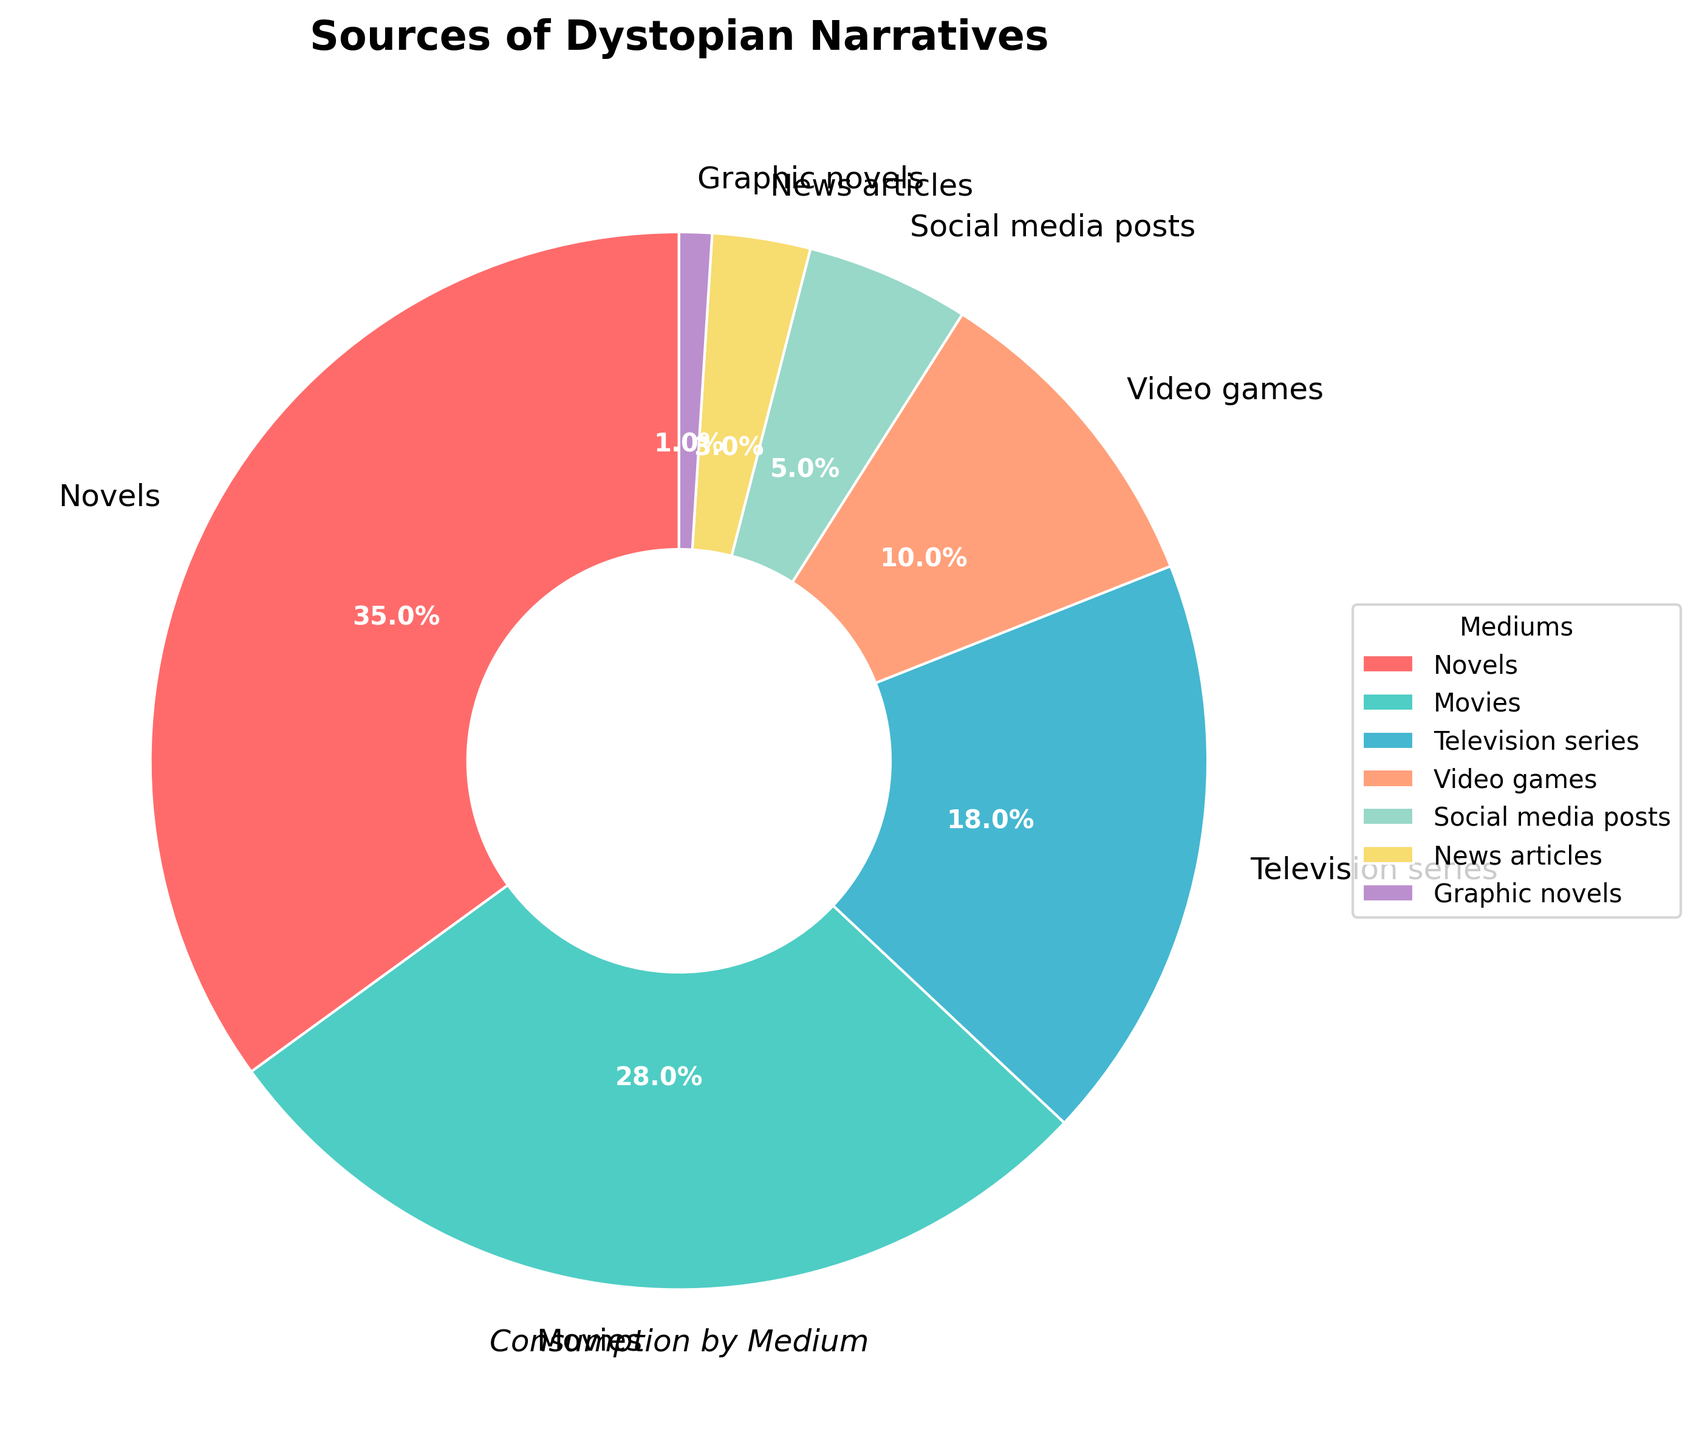Which medium has the highest percentage of dystopian narratives consumed? The pie chart shows that novels have the highest portion of the pie, indicating they have the highest percentage.
Answer: Novels What is the total percentage of dystopian narratives consumed through visual media (movies and television series)? Add the percentage of movies (28%) and television series (18%) together: 28% + 18% = 46%.
Answer: 46% Which medium has a smaller percentage of consumption, video games or social media posts? Compare the pie sections for video games (10%) and social media posts (5%). Social media posts are smaller.
Answer: Social media posts How much larger is the percentage of novels compared to news articles? Subtract the percentage of news articles (3%) from the percentage of novels (35%): 35% - 3% = 32%.
Answer: 32% What is the combined percentage of graphic novels and social media posts? Add the percentage of graphic novels (1%) and social media posts (5%): 1% + 5% = 6%.
Answer: 6% Which two mediums have a combined percentage of less than 10%? Graphic novels (1%) and news articles (3%) together make up 4%, which is less than 10%.
Answer: Graphic novels and news articles What is the difference between the percentage of movies and video games? Subtract the percentage of video games (10%) from the percentage of movies (28%): 28% - 10% = 18%.
Answer: 18% If the percentage of television series doubled, what would the new percentage be? Double the percentage of television series (18%): 18% * 2 = 36%.
Answer: 36% List the sources from highest to lowest percentage. The pie chart segments from largest to smallest are: Novels (35%), Movies (28%), Television series (18%), Video games (10%), Social media posts (5%), News articles (3%), Graphic novels (1%).
Answer: Novels, Movies, Television series, Video games, Social media posts, News articles, Graphic novels 